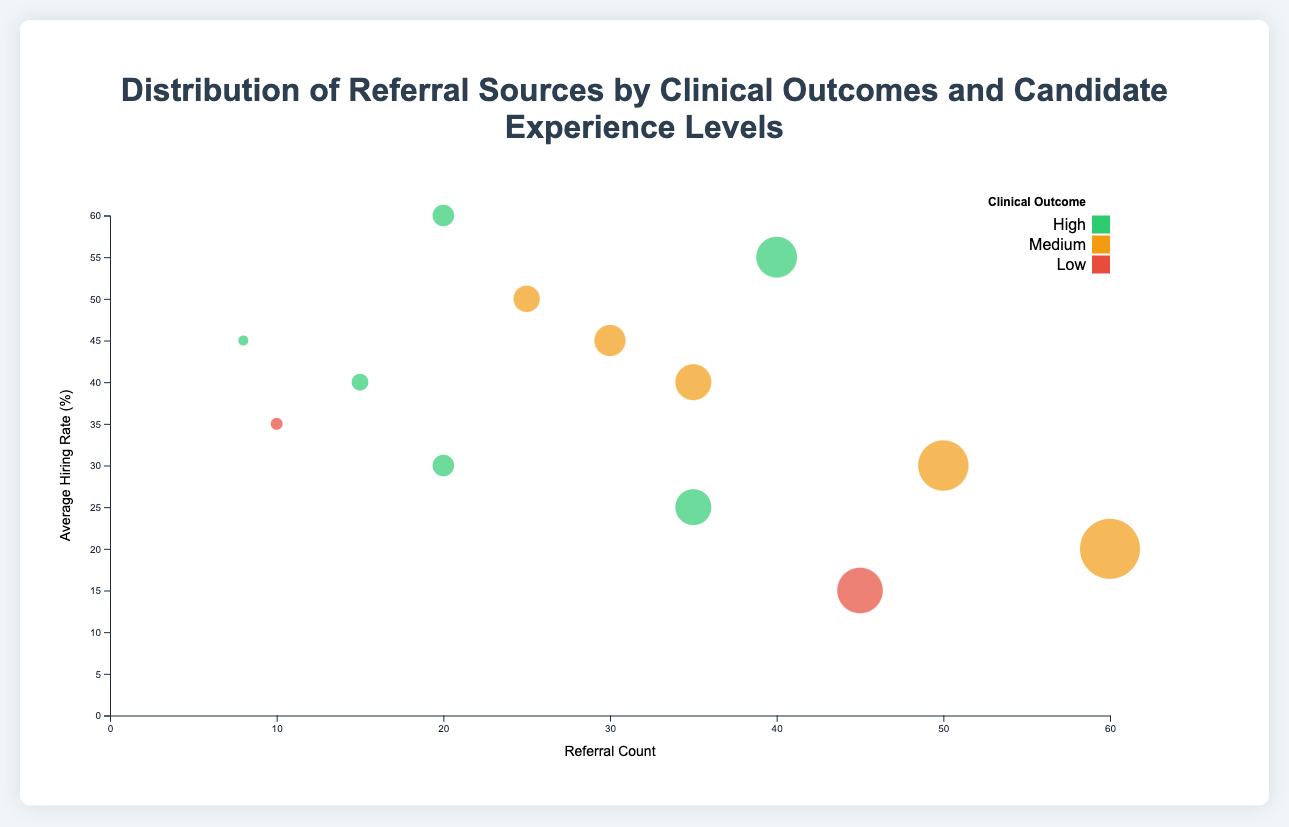How many referral sources are shown with a high clinical outcome? By observing the circles colored to represent high clinical outcomes (green), we count distinct referral sources. There are circles for "Online Job Portals," "Healthcare Networks," "University Alliances," "Staff Referrals," and "Job Fairs."
Answer: 5 Which experience level has the highest average hiring rate in referrals from job fairs? Looking at circles associated with "Job Fairs" and comparing their experience levels, "Intermediate" has the highest average hiring rate of 60%.
Answer: Intermediate Which referral source has the highest referral count? By examining the x-axis (Referral Count) and locating the furthest point to the right, "University Alliances" with an entry experience level and medium clinical outcome has the highest referral count (60).
Answer: University Alliances What is the difference in the average hiring rate between referrals from online job portals with high clinical outcomes and low clinical outcomes? Checking circles from "Online Job Portals," we see the difference between average hiring rates for high (25%) and low (15%) clinical outcomes is 25 - 15 = 10%.
Answer: 10% Which clinical outcome category has more data points? By counting the number of circles for each clinical outcome color: green (high), orange (medium), and red (low). High: 5, Medium: 5, Low: 3. Both high and medium have the most data points (5 each).
Answer: High and Medium What is the referral source with the lowest referral count for senior experience levels? Looking at circles with "Senior" experience and checking their x-axis values (Referral Count), "Healthcare Networks" with high clinical outcome has the lowest count (8).
Answer: Healthcare Networks Which data point shows the highest average hiring rate and what is its corresponding referral source and clinical outcome? Observing the highest point on the y-axis (Average Hiring Rate), we see it corresponds to "Job Fairs" with a "High" clinical outcome having an average hiring rate of 60%.
Answer: Job Fairs, High Which referral source has the most diverse (varied) clinical outcomes? Count the different clinical outcomes (colors) for each referral source: "Healthcare Networks" is identified with high (green), medium (orange), and low (red).
Answer: Healthcare Networks What is the ratio of referral counts between intermediate and senior experience levels for healthcare networks? Summing referral counts for "Healthcare Networks": Intermediate (25) and Senior (18). Ratio: 25/18.
Answer: 25:18 